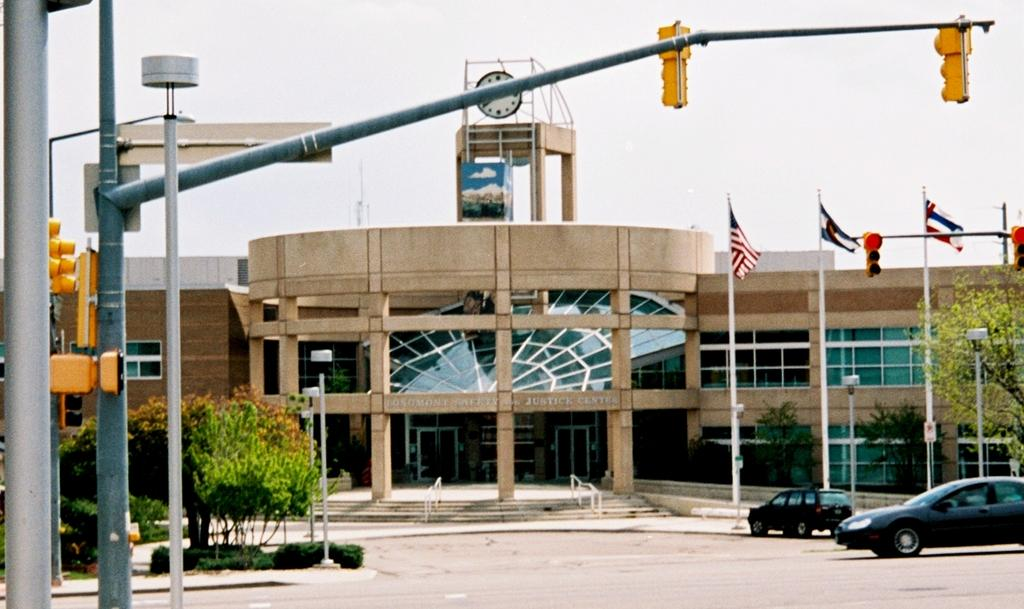What type of structure can be seen in the image? There is a building in the image. What are the flags associated with in the image? The flags are associated with the building in the image. What helps regulate traffic in the image? There are traffic signals in the image to help regulate traffic. What time-related object is present in the image? There is a clock in the image. How can people access different levels of the building in the image? There are stairs in the image for people to access different levels of the building. What type of vegetation is present in the image? There are trees in the image. What type of lighting is present in the image? There are lights in the image. What type of vehicles are present in the image? There are cars in the image. What part of the natural environment is visible in the image? The sky is visible in the image. What type of cakes are being served at the event in the image? There is no event or cakes present in the image. What type of paste is used to hold the grip on the wall in the image? There is no wall or grip present in the image. 